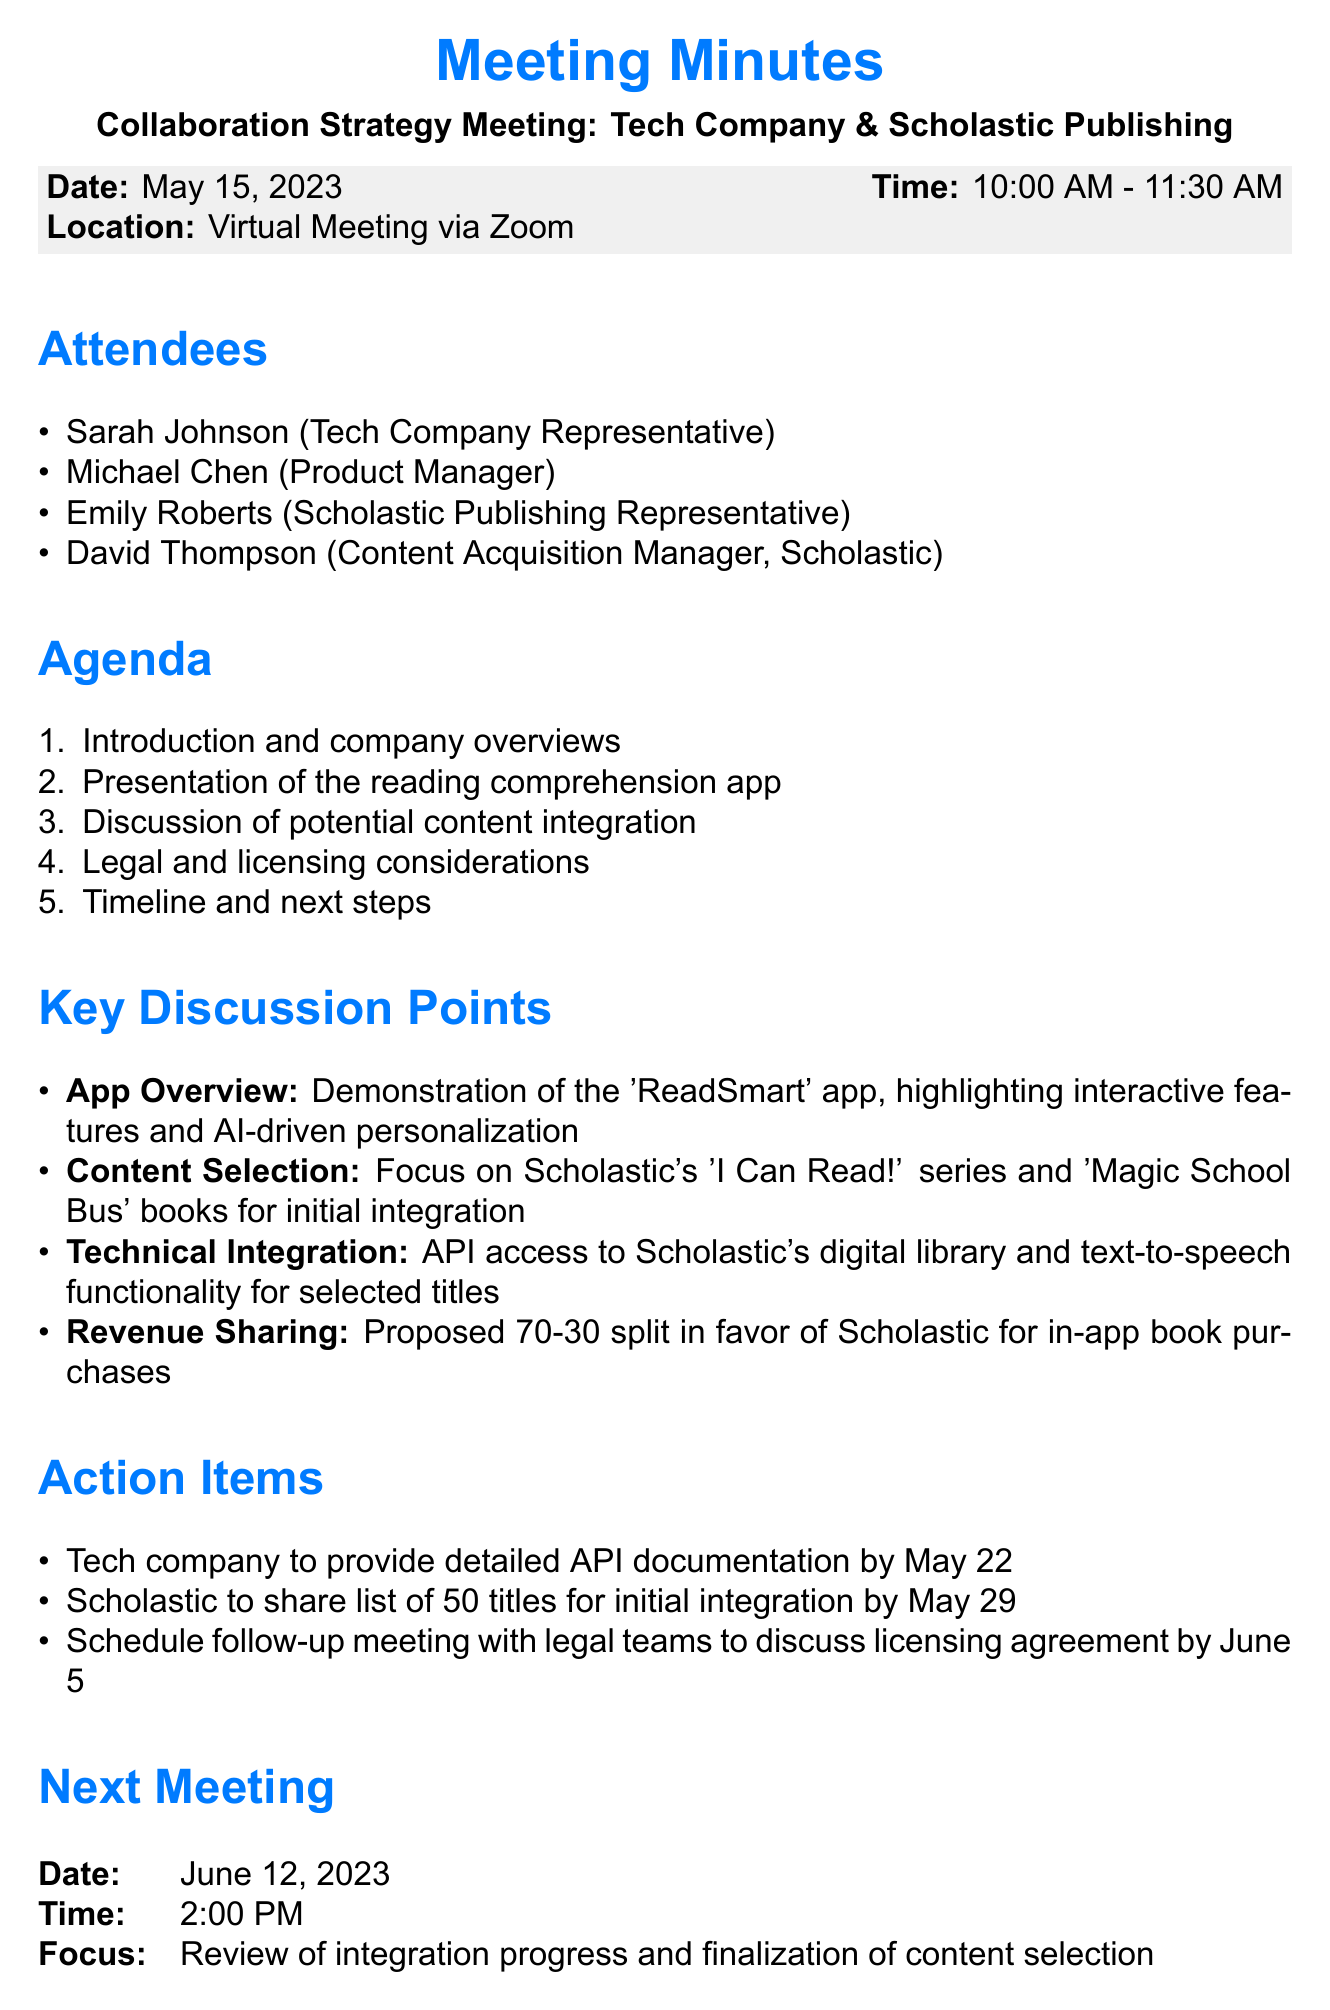What was the date of the meeting? The meeting took place on May 15, 2023, as stated in the meeting details section.
Answer: May 15, 2023 Who represented the tech company in the meeting? The document lists Sarah Johnson as the tech company representative among the attendees.
Answer: Sarah Johnson What time did the meeting start? The start time of the meeting is explicitly mentioned in the document as 10:00 AM.
Answer: 10:00 AM Which series of books was suggested for initial integration? The document specifies that the 'I Can Read!' series and 'Magic School Bus' books were discussed for content integration.
Answer: 'I Can Read!' series and 'Magic School Bus' What is the proposed revenue split for in-app purchases? The document details a proposed split of 70-30 in favor of Scholastic for in-app book purchases.
Answer: 70-30 When is the next meeting scheduled? The next meeting date is provided clearly in the document, noting it is scheduled for June 12, 2023.
Answer: June 12, 2023 What should the tech company provide by May 22? The action items section indicates that detailed API documentation is to be provided by May 22.
Answer: Detailed API documentation How many titles is Scholastic expected to share by May 29? The action items state that Scholastic is to share a list of 50 titles for initial integration.
Answer: 50 titles 